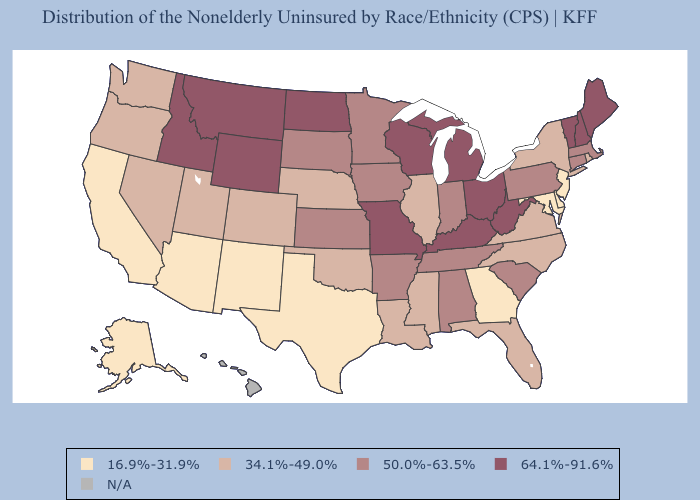Is the legend a continuous bar?
Keep it brief. No. Among the states that border Connecticut , does Massachusetts have the lowest value?
Short answer required. No. What is the value of New Mexico?
Give a very brief answer. 16.9%-31.9%. Name the states that have a value in the range 50.0%-63.5%?
Answer briefly. Alabama, Arkansas, Connecticut, Indiana, Iowa, Kansas, Massachusetts, Minnesota, Pennsylvania, South Carolina, South Dakota, Tennessee. Which states have the highest value in the USA?
Short answer required. Idaho, Kentucky, Maine, Michigan, Missouri, Montana, New Hampshire, North Dakota, Ohio, Vermont, West Virginia, Wisconsin, Wyoming. What is the lowest value in the USA?
Keep it brief. 16.9%-31.9%. Which states have the highest value in the USA?
Concise answer only. Idaho, Kentucky, Maine, Michigan, Missouri, Montana, New Hampshire, North Dakota, Ohio, Vermont, West Virginia, Wisconsin, Wyoming. What is the value of New Hampshire?
Be succinct. 64.1%-91.6%. What is the value of Pennsylvania?
Concise answer only. 50.0%-63.5%. How many symbols are there in the legend?
Quick response, please. 5. What is the value of Maryland?
Give a very brief answer. 16.9%-31.9%. What is the value of Alaska?
Give a very brief answer. 16.9%-31.9%. Does Connecticut have the highest value in the Northeast?
Give a very brief answer. No. Name the states that have a value in the range N/A?
Keep it brief. Hawaii. 